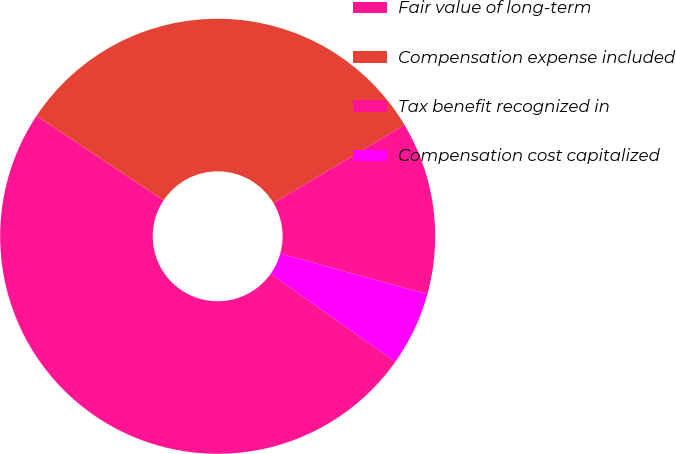Convert chart to OTSL. <chart><loc_0><loc_0><loc_500><loc_500><pie_chart><fcel>Fair value of long-term<fcel>Compensation expense included<fcel>Tax benefit recognized in<fcel>Compensation cost capitalized<nl><fcel>49.54%<fcel>32.11%<fcel>12.84%<fcel>5.5%<nl></chart> 